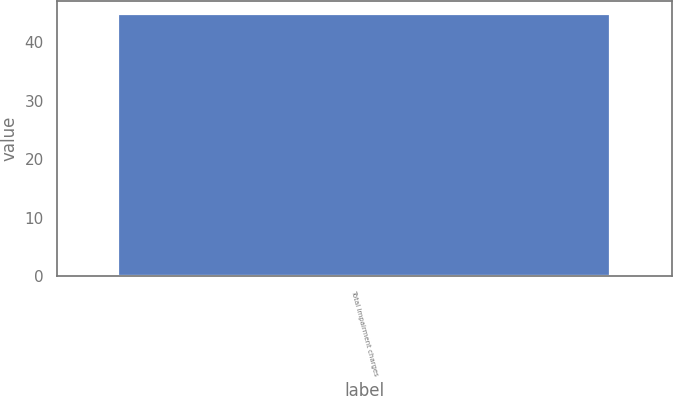<chart> <loc_0><loc_0><loc_500><loc_500><bar_chart><fcel>Total impairment charges<nl><fcel>44.8<nl></chart> 